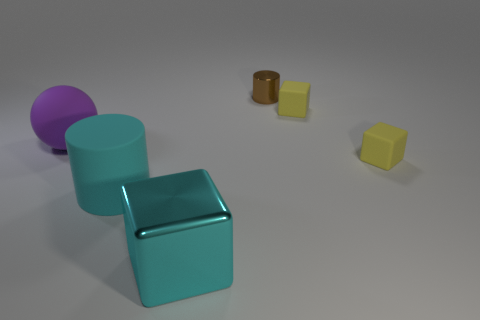How many big matte objects are the same color as the big block?
Provide a short and direct response. 1. What material is the small thing behind the small rubber thing that is behind the small matte object that is in front of the big purple matte object?
Provide a short and direct response. Metal. The big object that is right of the big cylinder has what shape?
Offer a terse response. Cube. What is the shape of the yellow rubber thing behind the matte object that is to the left of the cylinder that is to the left of the small metallic object?
Offer a terse response. Cube. What number of objects are either purple rubber things or yellow matte things?
Provide a succinct answer. 3. Does the cyan thing right of the large cyan cylinder have the same shape as the yellow rubber object behind the purple rubber thing?
Offer a very short reply. Yes. How many things are on the left side of the tiny brown metallic object and in front of the purple object?
Your answer should be compact. 2. How many other objects are there of the same size as the purple ball?
Give a very brief answer. 2. There is a thing that is to the left of the small brown cylinder and behind the big rubber cylinder; what is its material?
Your answer should be very brief. Rubber. There is a large rubber cylinder; is its color the same as the tiny thing in front of the matte sphere?
Keep it short and to the point. No. 